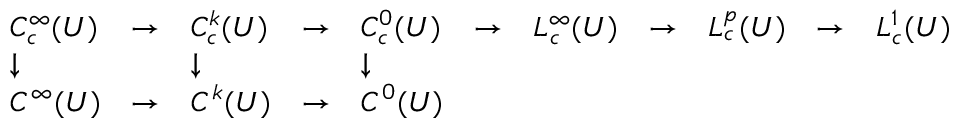Convert formula to latex. <formula><loc_0><loc_0><loc_500><loc_500>{ \begin{array} { l l l l l l l l l l l } { C _ { c } ^ { \infty } ( U ) } & { \to } & { C _ { c } ^ { k } ( U ) } & { \to } & { C _ { c } ^ { 0 } ( U ) } & { \to } & { L _ { c } ^ { \infty } ( U ) } & { \to } & { L _ { c } ^ { p } ( U ) } & { \to } & { L _ { c } ^ { 1 } ( U ) } \\ { \downarrow } & & { \downarrow } & & { \downarrow } \\ { C ^ { \infty } ( U ) } & { \to } & { C ^ { k } ( U ) } & { \to } & { C ^ { 0 } ( U ) } \end{array} }</formula> 